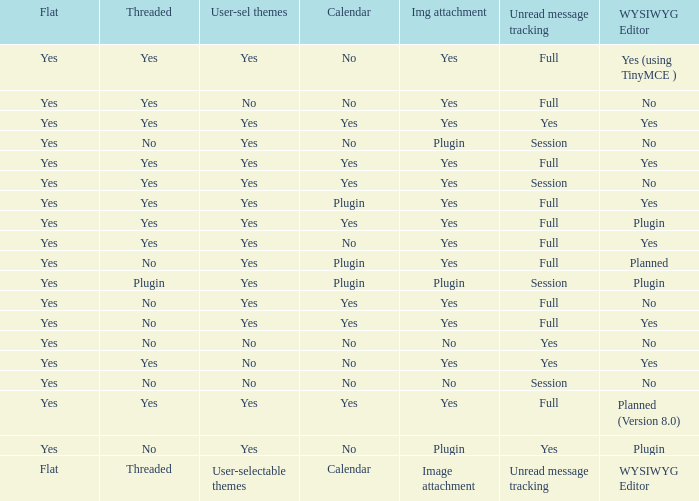Which Image attachment has a Threaded of yes, and a Calendar of yes? Yes, Yes, Yes, Yes, Yes. 